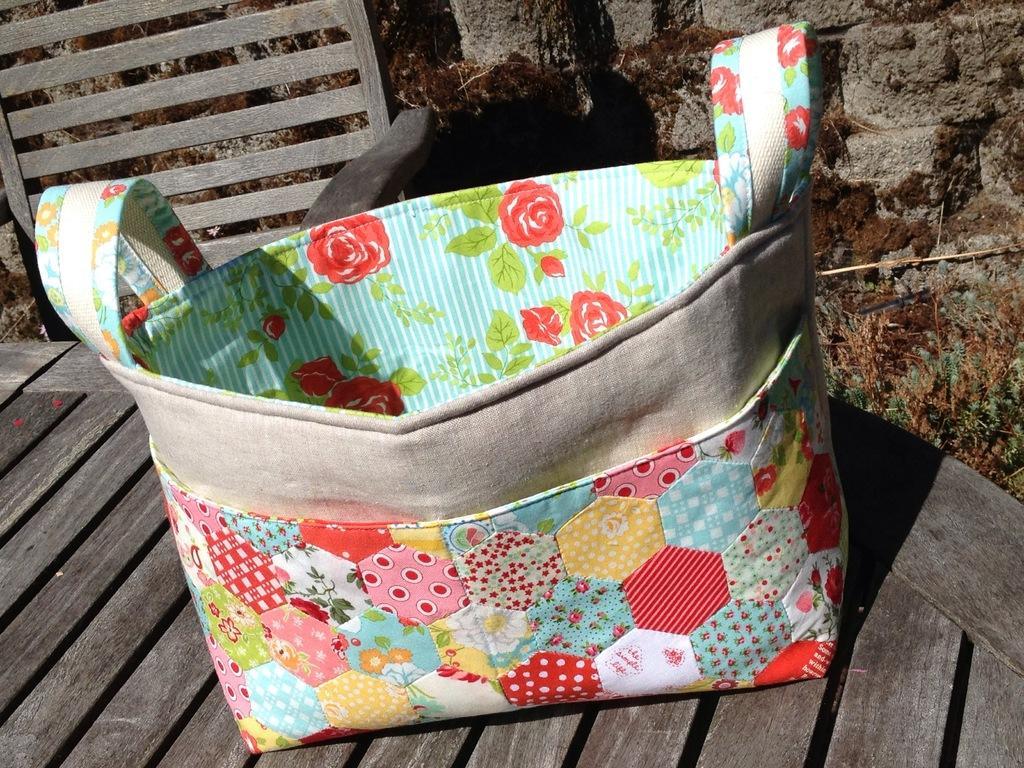In one or two sentences, can you explain what this image depicts? This image consists of a chair, which is wooden one and it has a bag on it ,which has flowers design on that. This bag has two handles and it is of multi color. 